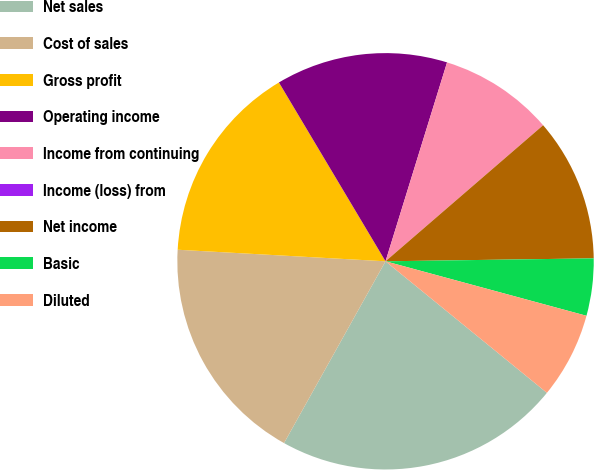Convert chart. <chart><loc_0><loc_0><loc_500><loc_500><pie_chart><fcel>Net sales<fcel>Cost of sales<fcel>Gross profit<fcel>Operating income<fcel>Income from continuing<fcel>Income (loss) from<fcel>Net income<fcel>Basic<fcel>Diluted<nl><fcel>22.22%<fcel>17.78%<fcel>15.56%<fcel>13.33%<fcel>8.89%<fcel>0.0%<fcel>11.11%<fcel>4.44%<fcel>6.67%<nl></chart> 